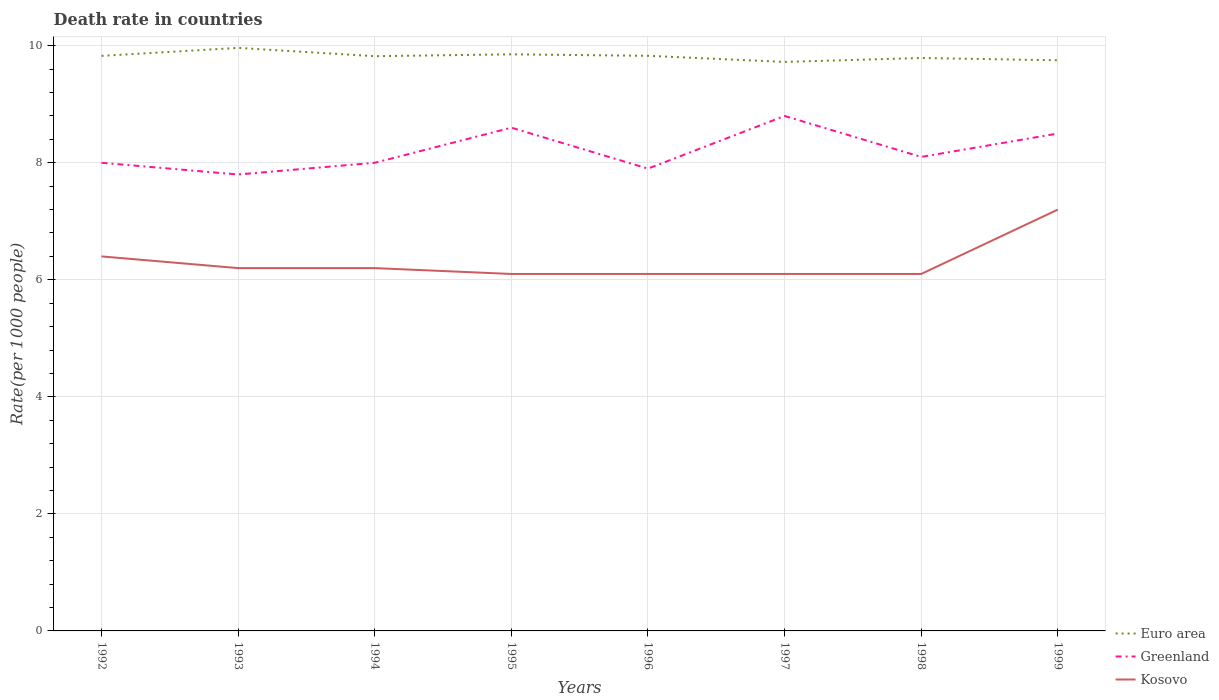How many different coloured lines are there?
Provide a succinct answer. 3. Across all years, what is the maximum death rate in Euro area?
Make the answer very short. 9.72. In which year was the death rate in Euro area maximum?
Ensure brevity in your answer.  1997. What is the total death rate in Euro area in the graph?
Give a very brief answer. -0.03. What is the difference between the highest and the second highest death rate in Greenland?
Give a very brief answer. 1. What is the difference between the highest and the lowest death rate in Kosovo?
Provide a short and direct response. 2. How many years are there in the graph?
Offer a terse response. 8. What is the difference between two consecutive major ticks on the Y-axis?
Give a very brief answer. 2. Does the graph contain grids?
Make the answer very short. Yes. How are the legend labels stacked?
Your response must be concise. Vertical. What is the title of the graph?
Keep it short and to the point. Death rate in countries. Does "Jamaica" appear as one of the legend labels in the graph?
Your answer should be very brief. No. What is the label or title of the X-axis?
Keep it short and to the point. Years. What is the label or title of the Y-axis?
Keep it short and to the point. Rate(per 1000 people). What is the Rate(per 1000 people) in Euro area in 1992?
Offer a very short reply. 9.83. What is the Rate(per 1000 people) in Euro area in 1993?
Your answer should be compact. 9.96. What is the Rate(per 1000 people) of Kosovo in 1993?
Provide a short and direct response. 6.2. What is the Rate(per 1000 people) of Euro area in 1994?
Your answer should be compact. 9.82. What is the Rate(per 1000 people) of Kosovo in 1994?
Offer a terse response. 6.2. What is the Rate(per 1000 people) in Euro area in 1995?
Give a very brief answer. 9.85. What is the Rate(per 1000 people) of Euro area in 1996?
Provide a short and direct response. 9.83. What is the Rate(per 1000 people) in Kosovo in 1996?
Provide a succinct answer. 6.1. What is the Rate(per 1000 people) of Euro area in 1997?
Offer a terse response. 9.72. What is the Rate(per 1000 people) of Greenland in 1997?
Your answer should be compact. 8.8. What is the Rate(per 1000 people) of Euro area in 1998?
Provide a short and direct response. 9.79. What is the Rate(per 1000 people) in Euro area in 1999?
Offer a very short reply. 9.75. What is the Rate(per 1000 people) of Kosovo in 1999?
Your answer should be compact. 7.2. Across all years, what is the maximum Rate(per 1000 people) of Euro area?
Provide a short and direct response. 9.96. Across all years, what is the minimum Rate(per 1000 people) in Euro area?
Make the answer very short. 9.72. Across all years, what is the minimum Rate(per 1000 people) in Greenland?
Your answer should be compact. 7.8. What is the total Rate(per 1000 people) in Euro area in the graph?
Your response must be concise. 78.56. What is the total Rate(per 1000 people) of Greenland in the graph?
Your answer should be compact. 65.7. What is the total Rate(per 1000 people) in Kosovo in the graph?
Your response must be concise. 50.4. What is the difference between the Rate(per 1000 people) in Euro area in 1992 and that in 1993?
Ensure brevity in your answer.  -0.14. What is the difference between the Rate(per 1000 people) of Greenland in 1992 and that in 1993?
Your answer should be very brief. 0.2. What is the difference between the Rate(per 1000 people) of Kosovo in 1992 and that in 1993?
Provide a succinct answer. 0.2. What is the difference between the Rate(per 1000 people) in Euro area in 1992 and that in 1994?
Offer a terse response. 0.01. What is the difference between the Rate(per 1000 people) in Kosovo in 1992 and that in 1994?
Your answer should be very brief. 0.2. What is the difference between the Rate(per 1000 people) of Euro area in 1992 and that in 1995?
Your response must be concise. -0.03. What is the difference between the Rate(per 1000 people) in Greenland in 1992 and that in 1995?
Keep it short and to the point. -0.6. What is the difference between the Rate(per 1000 people) of Kosovo in 1992 and that in 1995?
Your answer should be very brief. 0.3. What is the difference between the Rate(per 1000 people) of Euro area in 1992 and that in 1996?
Offer a very short reply. -0. What is the difference between the Rate(per 1000 people) of Kosovo in 1992 and that in 1996?
Your response must be concise. 0.3. What is the difference between the Rate(per 1000 people) of Euro area in 1992 and that in 1997?
Offer a terse response. 0.1. What is the difference between the Rate(per 1000 people) of Greenland in 1992 and that in 1997?
Provide a succinct answer. -0.8. What is the difference between the Rate(per 1000 people) of Euro area in 1992 and that in 1998?
Your answer should be compact. 0.04. What is the difference between the Rate(per 1000 people) of Greenland in 1992 and that in 1998?
Your answer should be very brief. -0.1. What is the difference between the Rate(per 1000 people) of Kosovo in 1992 and that in 1998?
Ensure brevity in your answer.  0.3. What is the difference between the Rate(per 1000 people) of Euro area in 1992 and that in 1999?
Your answer should be compact. 0.08. What is the difference between the Rate(per 1000 people) in Greenland in 1992 and that in 1999?
Your answer should be compact. -0.5. What is the difference between the Rate(per 1000 people) of Kosovo in 1992 and that in 1999?
Ensure brevity in your answer.  -0.8. What is the difference between the Rate(per 1000 people) in Euro area in 1993 and that in 1994?
Provide a short and direct response. 0.14. What is the difference between the Rate(per 1000 people) in Greenland in 1993 and that in 1994?
Your response must be concise. -0.2. What is the difference between the Rate(per 1000 people) in Euro area in 1993 and that in 1995?
Your response must be concise. 0.11. What is the difference between the Rate(per 1000 people) of Greenland in 1993 and that in 1995?
Provide a succinct answer. -0.8. What is the difference between the Rate(per 1000 people) of Euro area in 1993 and that in 1996?
Your response must be concise. 0.14. What is the difference between the Rate(per 1000 people) in Euro area in 1993 and that in 1997?
Your answer should be compact. 0.24. What is the difference between the Rate(per 1000 people) of Euro area in 1993 and that in 1998?
Give a very brief answer. 0.17. What is the difference between the Rate(per 1000 people) of Kosovo in 1993 and that in 1998?
Provide a short and direct response. 0.1. What is the difference between the Rate(per 1000 people) in Euro area in 1993 and that in 1999?
Your response must be concise. 0.21. What is the difference between the Rate(per 1000 people) in Greenland in 1993 and that in 1999?
Ensure brevity in your answer.  -0.7. What is the difference between the Rate(per 1000 people) of Euro area in 1994 and that in 1995?
Provide a succinct answer. -0.03. What is the difference between the Rate(per 1000 people) of Greenland in 1994 and that in 1995?
Your response must be concise. -0.6. What is the difference between the Rate(per 1000 people) in Euro area in 1994 and that in 1996?
Your response must be concise. -0.01. What is the difference between the Rate(per 1000 people) in Greenland in 1994 and that in 1996?
Make the answer very short. 0.1. What is the difference between the Rate(per 1000 people) in Kosovo in 1994 and that in 1996?
Ensure brevity in your answer.  0.1. What is the difference between the Rate(per 1000 people) of Euro area in 1994 and that in 1997?
Offer a very short reply. 0.1. What is the difference between the Rate(per 1000 people) of Euro area in 1994 and that in 1998?
Provide a succinct answer. 0.03. What is the difference between the Rate(per 1000 people) in Euro area in 1994 and that in 1999?
Your response must be concise. 0.07. What is the difference between the Rate(per 1000 people) of Greenland in 1994 and that in 1999?
Make the answer very short. -0.5. What is the difference between the Rate(per 1000 people) in Euro area in 1995 and that in 1996?
Your response must be concise. 0.03. What is the difference between the Rate(per 1000 people) of Greenland in 1995 and that in 1996?
Ensure brevity in your answer.  0.7. What is the difference between the Rate(per 1000 people) of Euro area in 1995 and that in 1997?
Offer a terse response. 0.13. What is the difference between the Rate(per 1000 people) of Euro area in 1995 and that in 1998?
Your answer should be compact. 0.06. What is the difference between the Rate(per 1000 people) of Kosovo in 1995 and that in 1998?
Make the answer very short. 0. What is the difference between the Rate(per 1000 people) of Euro area in 1995 and that in 1999?
Offer a terse response. 0.1. What is the difference between the Rate(per 1000 people) of Greenland in 1995 and that in 1999?
Offer a terse response. 0.1. What is the difference between the Rate(per 1000 people) in Euro area in 1996 and that in 1997?
Your answer should be compact. 0.1. What is the difference between the Rate(per 1000 people) in Greenland in 1996 and that in 1997?
Your response must be concise. -0.9. What is the difference between the Rate(per 1000 people) of Kosovo in 1996 and that in 1997?
Ensure brevity in your answer.  0. What is the difference between the Rate(per 1000 people) in Euro area in 1996 and that in 1998?
Ensure brevity in your answer.  0.04. What is the difference between the Rate(per 1000 people) in Greenland in 1996 and that in 1998?
Keep it short and to the point. -0.2. What is the difference between the Rate(per 1000 people) of Kosovo in 1996 and that in 1998?
Ensure brevity in your answer.  0. What is the difference between the Rate(per 1000 people) of Euro area in 1996 and that in 1999?
Your response must be concise. 0.08. What is the difference between the Rate(per 1000 people) in Euro area in 1997 and that in 1998?
Ensure brevity in your answer.  -0.07. What is the difference between the Rate(per 1000 people) of Kosovo in 1997 and that in 1998?
Offer a very short reply. 0. What is the difference between the Rate(per 1000 people) in Euro area in 1997 and that in 1999?
Offer a terse response. -0.03. What is the difference between the Rate(per 1000 people) in Greenland in 1997 and that in 1999?
Offer a very short reply. 0.3. What is the difference between the Rate(per 1000 people) of Kosovo in 1997 and that in 1999?
Offer a very short reply. -1.1. What is the difference between the Rate(per 1000 people) in Euro area in 1998 and that in 1999?
Keep it short and to the point. 0.04. What is the difference between the Rate(per 1000 people) in Kosovo in 1998 and that in 1999?
Provide a short and direct response. -1.1. What is the difference between the Rate(per 1000 people) in Euro area in 1992 and the Rate(per 1000 people) in Greenland in 1993?
Make the answer very short. 2.03. What is the difference between the Rate(per 1000 people) of Euro area in 1992 and the Rate(per 1000 people) of Kosovo in 1993?
Keep it short and to the point. 3.63. What is the difference between the Rate(per 1000 people) of Greenland in 1992 and the Rate(per 1000 people) of Kosovo in 1993?
Your answer should be very brief. 1.8. What is the difference between the Rate(per 1000 people) of Euro area in 1992 and the Rate(per 1000 people) of Greenland in 1994?
Your answer should be very brief. 1.83. What is the difference between the Rate(per 1000 people) of Euro area in 1992 and the Rate(per 1000 people) of Kosovo in 1994?
Keep it short and to the point. 3.63. What is the difference between the Rate(per 1000 people) in Euro area in 1992 and the Rate(per 1000 people) in Greenland in 1995?
Give a very brief answer. 1.23. What is the difference between the Rate(per 1000 people) of Euro area in 1992 and the Rate(per 1000 people) of Kosovo in 1995?
Provide a succinct answer. 3.73. What is the difference between the Rate(per 1000 people) of Greenland in 1992 and the Rate(per 1000 people) of Kosovo in 1995?
Give a very brief answer. 1.9. What is the difference between the Rate(per 1000 people) of Euro area in 1992 and the Rate(per 1000 people) of Greenland in 1996?
Ensure brevity in your answer.  1.93. What is the difference between the Rate(per 1000 people) of Euro area in 1992 and the Rate(per 1000 people) of Kosovo in 1996?
Your answer should be compact. 3.73. What is the difference between the Rate(per 1000 people) in Euro area in 1992 and the Rate(per 1000 people) in Greenland in 1997?
Keep it short and to the point. 1.03. What is the difference between the Rate(per 1000 people) in Euro area in 1992 and the Rate(per 1000 people) in Kosovo in 1997?
Your answer should be compact. 3.73. What is the difference between the Rate(per 1000 people) in Greenland in 1992 and the Rate(per 1000 people) in Kosovo in 1997?
Ensure brevity in your answer.  1.9. What is the difference between the Rate(per 1000 people) of Euro area in 1992 and the Rate(per 1000 people) of Greenland in 1998?
Ensure brevity in your answer.  1.73. What is the difference between the Rate(per 1000 people) in Euro area in 1992 and the Rate(per 1000 people) in Kosovo in 1998?
Provide a succinct answer. 3.73. What is the difference between the Rate(per 1000 people) in Greenland in 1992 and the Rate(per 1000 people) in Kosovo in 1998?
Offer a very short reply. 1.9. What is the difference between the Rate(per 1000 people) in Euro area in 1992 and the Rate(per 1000 people) in Greenland in 1999?
Make the answer very short. 1.33. What is the difference between the Rate(per 1000 people) in Euro area in 1992 and the Rate(per 1000 people) in Kosovo in 1999?
Offer a very short reply. 2.63. What is the difference between the Rate(per 1000 people) of Euro area in 1993 and the Rate(per 1000 people) of Greenland in 1994?
Give a very brief answer. 1.96. What is the difference between the Rate(per 1000 people) in Euro area in 1993 and the Rate(per 1000 people) in Kosovo in 1994?
Offer a terse response. 3.76. What is the difference between the Rate(per 1000 people) of Greenland in 1993 and the Rate(per 1000 people) of Kosovo in 1994?
Your response must be concise. 1.6. What is the difference between the Rate(per 1000 people) of Euro area in 1993 and the Rate(per 1000 people) of Greenland in 1995?
Your answer should be very brief. 1.36. What is the difference between the Rate(per 1000 people) of Euro area in 1993 and the Rate(per 1000 people) of Kosovo in 1995?
Keep it short and to the point. 3.86. What is the difference between the Rate(per 1000 people) in Euro area in 1993 and the Rate(per 1000 people) in Greenland in 1996?
Keep it short and to the point. 2.06. What is the difference between the Rate(per 1000 people) of Euro area in 1993 and the Rate(per 1000 people) of Kosovo in 1996?
Give a very brief answer. 3.86. What is the difference between the Rate(per 1000 people) in Euro area in 1993 and the Rate(per 1000 people) in Greenland in 1997?
Ensure brevity in your answer.  1.16. What is the difference between the Rate(per 1000 people) of Euro area in 1993 and the Rate(per 1000 people) of Kosovo in 1997?
Offer a terse response. 3.86. What is the difference between the Rate(per 1000 people) of Euro area in 1993 and the Rate(per 1000 people) of Greenland in 1998?
Keep it short and to the point. 1.86. What is the difference between the Rate(per 1000 people) of Euro area in 1993 and the Rate(per 1000 people) of Kosovo in 1998?
Offer a terse response. 3.86. What is the difference between the Rate(per 1000 people) of Greenland in 1993 and the Rate(per 1000 people) of Kosovo in 1998?
Offer a terse response. 1.7. What is the difference between the Rate(per 1000 people) in Euro area in 1993 and the Rate(per 1000 people) in Greenland in 1999?
Ensure brevity in your answer.  1.46. What is the difference between the Rate(per 1000 people) in Euro area in 1993 and the Rate(per 1000 people) in Kosovo in 1999?
Your response must be concise. 2.76. What is the difference between the Rate(per 1000 people) in Euro area in 1994 and the Rate(per 1000 people) in Greenland in 1995?
Provide a succinct answer. 1.22. What is the difference between the Rate(per 1000 people) of Euro area in 1994 and the Rate(per 1000 people) of Kosovo in 1995?
Provide a succinct answer. 3.72. What is the difference between the Rate(per 1000 people) in Euro area in 1994 and the Rate(per 1000 people) in Greenland in 1996?
Provide a short and direct response. 1.92. What is the difference between the Rate(per 1000 people) in Euro area in 1994 and the Rate(per 1000 people) in Kosovo in 1996?
Provide a short and direct response. 3.72. What is the difference between the Rate(per 1000 people) in Euro area in 1994 and the Rate(per 1000 people) in Greenland in 1997?
Give a very brief answer. 1.02. What is the difference between the Rate(per 1000 people) in Euro area in 1994 and the Rate(per 1000 people) in Kosovo in 1997?
Keep it short and to the point. 3.72. What is the difference between the Rate(per 1000 people) in Greenland in 1994 and the Rate(per 1000 people) in Kosovo in 1997?
Provide a succinct answer. 1.9. What is the difference between the Rate(per 1000 people) in Euro area in 1994 and the Rate(per 1000 people) in Greenland in 1998?
Keep it short and to the point. 1.72. What is the difference between the Rate(per 1000 people) of Euro area in 1994 and the Rate(per 1000 people) of Kosovo in 1998?
Offer a very short reply. 3.72. What is the difference between the Rate(per 1000 people) of Greenland in 1994 and the Rate(per 1000 people) of Kosovo in 1998?
Your response must be concise. 1.9. What is the difference between the Rate(per 1000 people) in Euro area in 1994 and the Rate(per 1000 people) in Greenland in 1999?
Provide a short and direct response. 1.32. What is the difference between the Rate(per 1000 people) of Euro area in 1994 and the Rate(per 1000 people) of Kosovo in 1999?
Make the answer very short. 2.62. What is the difference between the Rate(per 1000 people) in Greenland in 1994 and the Rate(per 1000 people) in Kosovo in 1999?
Offer a terse response. 0.8. What is the difference between the Rate(per 1000 people) of Euro area in 1995 and the Rate(per 1000 people) of Greenland in 1996?
Your answer should be compact. 1.95. What is the difference between the Rate(per 1000 people) of Euro area in 1995 and the Rate(per 1000 people) of Kosovo in 1996?
Keep it short and to the point. 3.75. What is the difference between the Rate(per 1000 people) in Euro area in 1995 and the Rate(per 1000 people) in Greenland in 1997?
Give a very brief answer. 1.05. What is the difference between the Rate(per 1000 people) in Euro area in 1995 and the Rate(per 1000 people) in Kosovo in 1997?
Make the answer very short. 3.75. What is the difference between the Rate(per 1000 people) of Greenland in 1995 and the Rate(per 1000 people) of Kosovo in 1997?
Provide a short and direct response. 2.5. What is the difference between the Rate(per 1000 people) in Euro area in 1995 and the Rate(per 1000 people) in Greenland in 1998?
Your answer should be very brief. 1.75. What is the difference between the Rate(per 1000 people) of Euro area in 1995 and the Rate(per 1000 people) of Kosovo in 1998?
Your answer should be compact. 3.75. What is the difference between the Rate(per 1000 people) in Euro area in 1995 and the Rate(per 1000 people) in Greenland in 1999?
Your answer should be compact. 1.35. What is the difference between the Rate(per 1000 people) of Euro area in 1995 and the Rate(per 1000 people) of Kosovo in 1999?
Offer a very short reply. 2.65. What is the difference between the Rate(per 1000 people) of Euro area in 1996 and the Rate(per 1000 people) of Greenland in 1997?
Your answer should be compact. 1.03. What is the difference between the Rate(per 1000 people) in Euro area in 1996 and the Rate(per 1000 people) in Kosovo in 1997?
Your response must be concise. 3.73. What is the difference between the Rate(per 1000 people) of Euro area in 1996 and the Rate(per 1000 people) of Greenland in 1998?
Ensure brevity in your answer.  1.73. What is the difference between the Rate(per 1000 people) of Euro area in 1996 and the Rate(per 1000 people) of Kosovo in 1998?
Give a very brief answer. 3.73. What is the difference between the Rate(per 1000 people) in Euro area in 1996 and the Rate(per 1000 people) in Greenland in 1999?
Your response must be concise. 1.33. What is the difference between the Rate(per 1000 people) of Euro area in 1996 and the Rate(per 1000 people) of Kosovo in 1999?
Keep it short and to the point. 2.63. What is the difference between the Rate(per 1000 people) of Euro area in 1997 and the Rate(per 1000 people) of Greenland in 1998?
Your answer should be very brief. 1.62. What is the difference between the Rate(per 1000 people) in Euro area in 1997 and the Rate(per 1000 people) in Kosovo in 1998?
Your answer should be very brief. 3.62. What is the difference between the Rate(per 1000 people) in Euro area in 1997 and the Rate(per 1000 people) in Greenland in 1999?
Make the answer very short. 1.22. What is the difference between the Rate(per 1000 people) in Euro area in 1997 and the Rate(per 1000 people) in Kosovo in 1999?
Make the answer very short. 2.52. What is the difference between the Rate(per 1000 people) of Greenland in 1997 and the Rate(per 1000 people) of Kosovo in 1999?
Give a very brief answer. 1.6. What is the difference between the Rate(per 1000 people) of Euro area in 1998 and the Rate(per 1000 people) of Greenland in 1999?
Provide a succinct answer. 1.29. What is the difference between the Rate(per 1000 people) in Euro area in 1998 and the Rate(per 1000 people) in Kosovo in 1999?
Provide a short and direct response. 2.59. What is the average Rate(per 1000 people) of Euro area per year?
Give a very brief answer. 9.82. What is the average Rate(per 1000 people) in Greenland per year?
Give a very brief answer. 8.21. In the year 1992, what is the difference between the Rate(per 1000 people) in Euro area and Rate(per 1000 people) in Greenland?
Offer a very short reply. 1.83. In the year 1992, what is the difference between the Rate(per 1000 people) of Euro area and Rate(per 1000 people) of Kosovo?
Provide a succinct answer. 3.43. In the year 1992, what is the difference between the Rate(per 1000 people) of Greenland and Rate(per 1000 people) of Kosovo?
Your answer should be compact. 1.6. In the year 1993, what is the difference between the Rate(per 1000 people) in Euro area and Rate(per 1000 people) in Greenland?
Your answer should be compact. 2.16. In the year 1993, what is the difference between the Rate(per 1000 people) in Euro area and Rate(per 1000 people) in Kosovo?
Keep it short and to the point. 3.76. In the year 1993, what is the difference between the Rate(per 1000 people) of Greenland and Rate(per 1000 people) of Kosovo?
Your answer should be very brief. 1.6. In the year 1994, what is the difference between the Rate(per 1000 people) of Euro area and Rate(per 1000 people) of Greenland?
Provide a short and direct response. 1.82. In the year 1994, what is the difference between the Rate(per 1000 people) of Euro area and Rate(per 1000 people) of Kosovo?
Ensure brevity in your answer.  3.62. In the year 1994, what is the difference between the Rate(per 1000 people) in Greenland and Rate(per 1000 people) in Kosovo?
Give a very brief answer. 1.8. In the year 1995, what is the difference between the Rate(per 1000 people) in Euro area and Rate(per 1000 people) in Greenland?
Give a very brief answer. 1.25. In the year 1995, what is the difference between the Rate(per 1000 people) of Euro area and Rate(per 1000 people) of Kosovo?
Give a very brief answer. 3.75. In the year 1996, what is the difference between the Rate(per 1000 people) of Euro area and Rate(per 1000 people) of Greenland?
Give a very brief answer. 1.93. In the year 1996, what is the difference between the Rate(per 1000 people) of Euro area and Rate(per 1000 people) of Kosovo?
Keep it short and to the point. 3.73. In the year 1997, what is the difference between the Rate(per 1000 people) of Euro area and Rate(per 1000 people) of Greenland?
Offer a terse response. 0.92. In the year 1997, what is the difference between the Rate(per 1000 people) of Euro area and Rate(per 1000 people) of Kosovo?
Ensure brevity in your answer.  3.62. In the year 1998, what is the difference between the Rate(per 1000 people) in Euro area and Rate(per 1000 people) in Greenland?
Keep it short and to the point. 1.69. In the year 1998, what is the difference between the Rate(per 1000 people) in Euro area and Rate(per 1000 people) in Kosovo?
Make the answer very short. 3.69. In the year 1999, what is the difference between the Rate(per 1000 people) in Euro area and Rate(per 1000 people) in Greenland?
Your answer should be compact. 1.25. In the year 1999, what is the difference between the Rate(per 1000 people) of Euro area and Rate(per 1000 people) of Kosovo?
Ensure brevity in your answer.  2.55. In the year 1999, what is the difference between the Rate(per 1000 people) of Greenland and Rate(per 1000 people) of Kosovo?
Ensure brevity in your answer.  1.3. What is the ratio of the Rate(per 1000 people) in Euro area in 1992 to that in 1993?
Keep it short and to the point. 0.99. What is the ratio of the Rate(per 1000 people) of Greenland in 1992 to that in 1993?
Your answer should be very brief. 1.03. What is the ratio of the Rate(per 1000 people) in Kosovo in 1992 to that in 1993?
Keep it short and to the point. 1.03. What is the ratio of the Rate(per 1000 people) in Euro area in 1992 to that in 1994?
Give a very brief answer. 1. What is the ratio of the Rate(per 1000 people) of Greenland in 1992 to that in 1994?
Offer a very short reply. 1. What is the ratio of the Rate(per 1000 people) in Kosovo in 1992 to that in 1994?
Your answer should be compact. 1.03. What is the ratio of the Rate(per 1000 people) of Euro area in 1992 to that in 1995?
Provide a short and direct response. 1. What is the ratio of the Rate(per 1000 people) of Greenland in 1992 to that in 1995?
Make the answer very short. 0.93. What is the ratio of the Rate(per 1000 people) in Kosovo in 1992 to that in 1995?
Your response must be concise. 1.05. What is the ratio of the Rate(per 1000 people) of Greenland in 1992 to that in 1996?
Keep it short and to the point. 1.01. What is the ratio of the Rate(per 1000 people) in Kosovo in 1992 to that in 1996?
Your answer should be very brief. 1.05. What is the ratio of the Rate(per 1000 people) in Euro area in 1992 to that in 1997?
Offer a very short reply. 1.01. What is the ratio of the Rate(per 1000 people) in Greenland in 1992 to that in 1997?
Keep it short and to the point. 0.91. What is the ratio of the Rate(per 1000 people) of Kosovo in 1992 to that in 1997?
Offer a very short reply. 1.05. What is the ratio of the Rate(per 1000 people) of Kosovo in 1992 to that in 1998?
Your answer should be very brief. 1.05. What is the ratio of the Rate(per 1000 people) in Euro area in 1993 to that in 1994?
Offer a terse response. 1.01. What is the ratio of the Rate(per 1000 people) of Kosovo in 1993 to that in 1994?
Keep it short and to the point. 1. What is the ratio of the Rate(per 1000 people) in Euro area in 1993 to that in 1995?
Offer a terse response. 1.01. What is the ratio of the Rate(per 1000 people) of Greenland in 1993 to that in 1995?
Your response must be concise. 0.91. What is the ratio of the Rate(per 1000 people) in Kosovo in 1993 to that in 1995?
Ensure brevity in your answer.  1.02. What is the ratio of the Rate(per 1000 people) of Euro area in 1993 to that in 1996?
Your response must be concise. 1.01. What is the ratio of the Rate(per 1000 people) in Greenland in 1993 to that in 1996?
Your answer should be compact. 0.99. What is the ratio of the Rate(per 1000 people) of Kosovo in 1993 to that in 1996?
Keep it short and to the point. 1.02. What is the ratio of the Rate(per 1000 people) in Euro area in 1993 to that in 1997?
Provide a succinct answer. 1.02. What is the ratio of the Rate(per 1000 people) of Greenland in 1993 to that in 1997?
Give a very brief answer. 0.89. What is the ratio of the Rate(per 1000 people) in Kosovo in 1993 to that in 1997?
Keep it short and to the point. 1.02. What is the ratio of the Rate(per 1000 people) in Euro area in 1993 to that in 1998?
Your answer should be compact. 1.02. What is the ratio of the Rate(per 1000 people) in Kosovo in 1993 to that in 1998?
Provide a short and direct response. 1.02. What is the ratio of the Rate(per 1000 people) of Euro area in 1993 to that in 1999?
Your answer should be very brief. 1.02. What is the ratio of the Rate(per 1000 people) of Greenland in 1993 to that in 1999?
Your answer should be compact. 0.92. What is the ratio of the Rate(per 1000 people) in Kosovo in 1993 to that in 1999?
Your answer should be very brief. 0.86. What is the ratio of the Rate(per 1000 people) of Euro area in 1994 to that in 1995?
Offer a very short reply. 1. What is the ratio of the Rate(per 1000 people) of Greenland in 1994 to that in 1995?
Your answer should be very brief. 0.93. What is the ratio of the Rate(per 1000 people) of Kosovo in 1994 to that in 1995?
Provide a succinct answer. 1.02. What is the ratio of the Rate(per 1000 people) of Euro area in 1994 to that in 1996?
Provide a succinct answer. 1. What is the ratio of the Rate(per 1000 people) in Greenland in 1994 to that in 1996?
Provide a succinct answer. 1.01. What is the ratio of the Rate(per 1000 people) of Kosovo in 1994 to that in 1996?
Provide a succinct answer. 1.02. What is the ratio of the Rate(per 1000 people) in Euro area in 1994 to that in 1997?
Your answer should be very brief. 1.01. What is the ratio of the Rate(per 1000 people) of Kosovo in 1994 to that in 1997?
Ensure brevity in your answer.  1.02. What is the ratio of the Rate(per 1000 people) in Kosovo in 1994 to that in 1998?
Provide a succinct answer. 1.02. What is the ratio of the Rate(per 1000 people) in Greenland in 1994 to that in 1999?
Your answer should be compact. 0.94. What is the ratio of the Rate(per 1000 people) in Kosovo in 1994 to that in 1999?
Provide a succinct answer. 0.86. What is the ratio of the Rate(per 1000 people) in Greenland in 1995 to that in 1996?
Give a very brief answer. 1.09. What is the ratio of the Rate(per 1000 people) of Kosovo in 1995 to that in 1996?
Provide a succinct answer. 1. What is the ratio of the Rate(per 1000 people) in Euro area in 1995 to that in 1997?
Provide a succinct answer. 1.01. What is the ratio of the Rate(per 1000 people) in Greenland in 1995 to that in 1997?
Offer a terse response. 0.98. What is the ratio of the Rate(per 1000 people) of Euro area in 1995 to that in 1998?
Ensure brevity in your answer.  1.01. What is the ratio of the Rate(per 1000 people) in Greenland in 1995 to that in 1998?
Keep it short and to the point. 1.06. What is the ratio of the Rate(per 1000 people) in Kosovo in 1995 to that in 1998?
Make the answer very short. 1. What is the ratio of the Rate(per 1000 people) in Euro area in 1995 to that in 1999?
Make the answer very short. 1.01. What is the ratio of the Rate(per 1000 people) of Greenland in 1995 to that in 1999?
Make the answer very short. 1.01. What is the ratio of the Rate(per 1000 people) in Kosovo in 1995 to that in 1999?
Your response must be concise. 0.85. What is the ratio of the Rate(per 1000 people) of Euro area in 1996 to that in 1997?
Your response must be concise. 1.01. What is the ratio of the Rate(per 1000 people) in Greenland in 1996 to that in 1997?
Your response must be concise. 0.9. What is the ratio of the Rate(per 1000 people) of Greenland in 1996 to that in 1998?
Your answer should be very brief. 0.98. What is the ratio of the Rate(per 1000 people) in Euro area in 1996 to that in 1999?
Provide a succinct answer. 1.01. What is the ratio of the Rate(per 1000 people) in Greenland in 1996 to that in 1999?
Ensure brevity in your answer.  0.93. What is the ratio of the Rate(per 1000 people) in Kosovo in 1996 to that in 1999?
Keep it short and to the point. 0.85. What is the ratio of the Rate(per 1000 people) in Greenland in 1997 to that in 1998?
Your response must be concise. 1.09. What is the ratio of the Rate(per 1000 people) in Greenland in 1997 to that in 1999?
Your answer should be compact. 1.04. What is the ratio of the Rate(per 1000 people) of Kosovo in 1997 to that in 1999?
Your response must be concise. 0.85. What is the ratio of the Rate(per 1000 people) of Greenland in 1998 to that in 1999?
Make the answer very short. 0.95. What is the ratio of the Rate(per 1000 people) of Kosovo in 1998 to that in 1999?
Keep it short and to the point. 0.85. What is the difference between the highest and the second highest Rate(per 1000 people) in Euro area?
Offer a terse response. 0.11. What is the difference between the highest and the second highest Rate(per 1000 people) in Greenland?
Your answer should be very brief. 0.2. What is the difference between the highest and the lowest Rate(per 1000 people) of Euro area?
Offer a very short reply. 0.24. What is the difference between the highest and the lowest Rate(per 1000 people) in Greenland?
Provide a short and direct response. 1. 